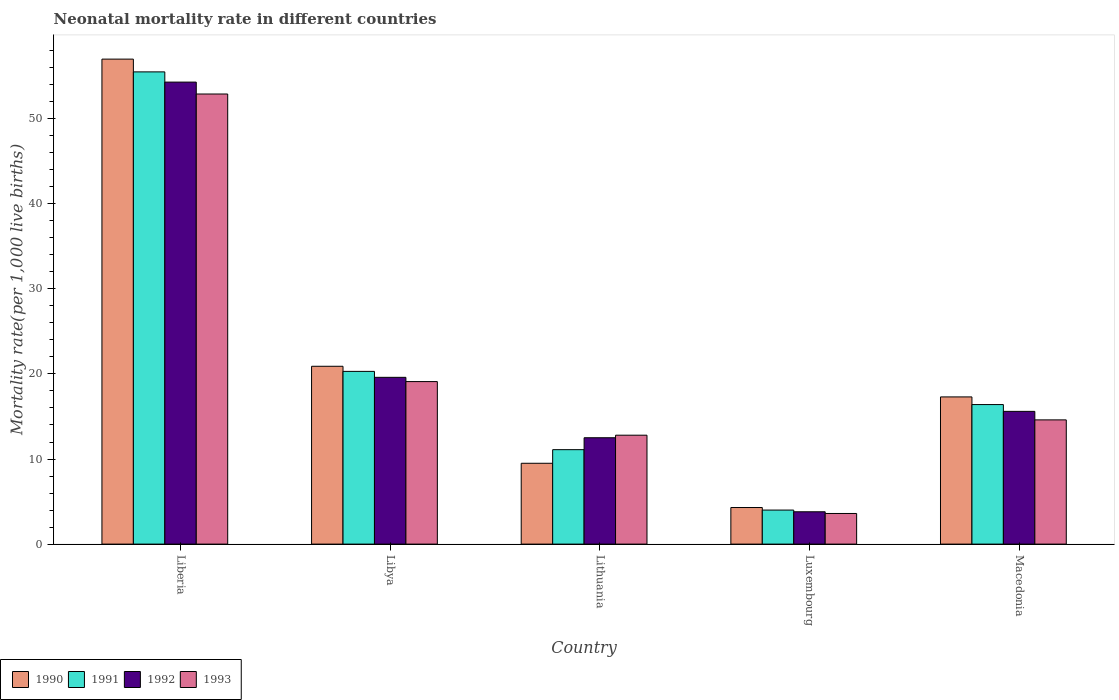How many different coloured bars are there?
Your answer should be very brief. 4. How many groups of bars are there?
Keep it short and to the point. 5. Are the number of bars on each tick of the X-axis equal?
Make the answer very short. Yes. How many bars are there on the 2nd tick from the left?
Make the answer very short. 4. How many bars are there on the 1st tick from the right?
Keep it short and to the point. 4. What is the label of the 1st group of bars from the left?
Your answer should be very brief. Liberia. In how many cases, is the number of bars for a given country not equal to the number of legend labels?
Your answer should be compact. 0. Across all countries, what is the maximum neonatal mortality rate in 1992?
Ensure brevity in your answer.  54.3. Across all countries, what is the minimum neonatal mortality rate in 1991?
Keep it short and to the point. 4. In which country was the neonatal mortality rate in 1991 maximum?
Provide a short and direct response. Liberia. In which country was the neonatal mortality rate in 1991 minimum?
Make the answer very short. Luxembourg. What is the total neonatal mortality rate in 1992 in the graph?
Give a very brief answer. 105.8. What is the difference between the neonatal mortality rate in 1991 in Liberia and that in Macedonia?
Provide a short and direct response. 39.1. What is the average neonatal mortality rate in 1992 per country?
Your answer should be compact. 21.16. What is the difference between the neonatal mortality rate of/in 1992 and neonatal mortality rate of/in 1993 in Luxembourg?
Ensure brevity in your answer.  0.2. In how many countries, is the neonatal mortality rate in 1991 greater than 14?
Provide a succinct answer. 3. What is the ratio of the neonatal mortality rate in 1992 in Liberia to that in Libya?
Provide a succinct answer. 2.77. Is the neonatal mortality rate in 1990 in Lithuania less than that in Macedonia?
Ensure brevity in your answer.  Yes. Is the difference between the neonatal mortality rate in 1992 in Libya and Macedonia greater than the difference between the neonatal mortality rate in 1993 in Libya and Macedonia?
Give a very brief answer. No. What is the difference between the highest and the second highest neonatal mortality rate in 1993?
Offer a terse response. -33.8. What is the difference between the highest and the lowest neonatal mortality rate in 1992?
Ensure brevity in your answer.  50.5. Is it the case that in every country, the sum of the neonatal mortality rate in 1992 and neonatal mortality rate in 1993 is greater than the sum of neonatal mortality rate in 1990 and neonatal mortality rate in 1991?
Provide a succinct answer. No. How many bars are there?
Make the answer very short. 20. Are all the bars in the graph horizontal?
Your answer should be compact. No. How many countries are there in the graph?
Make the answer very short. 5. Are the values on the major ticks of Y-axis written in scientific E-notation?
Make the answer very short. No. Does the graph contain any zero values?
Your response must be concise. No. Where does the legend appear in the graph?
Your answer should be very brief. Bottom left. How many legend labels are there?
Your answer should be very brief. 4. How are the legend labels stacked?
Offer a very short reply. Horizontal. What is the title of the graph?
Provide a succinct answer. Neonatal mortality rate in different countries. Does "2004" appear as one of the legend labels in the graph?
Your answer should be very brief. No. What is the label or title of the Y-axis?
Offer a very short reply. Mortality rate(per 1,0 live births). What is the Mortality rate(per 1,000 live births) of 1990 in Liberia?
Give a very brief answer. 57. What is the Mortality rate(per 1,000 live births) in 1991 in Liberia?
Offer a very short reply. 55.5. What is the Mortality rate(per 1,000 live births) in 1992 in Liberia?
Keep it short and to the point. 54.3. What is the Mortality rate(per 1,000 live births) in 1993 in Liberia?
Offer a very short reply. 52.9. What is the Mortality rate(per 1,000 live births) of 1990 in Libya?
Your answer should be very brief. 20.9. What is the Mortality rate(per 1,000 live births) in 1991 in Libya?
Your response must be concise. 20.3. What is the Mortality rate(per 1,000 live births) in 1992 in Libya?
Offer a terse response. 19.6. What is the Mortality rate(per 1,000 live births) in 1990 in Lithuania?
Ensure brevity in your answer.  9.5. What is the Mortality rate(per 1,000 live births) in 1991 in Lithuania?
Keep it short and to the point. 11.1. What is the Mortality rate(per 1,000 live births) in 1992 in Lithuania?
Provide a succinct answer. 12.5. What is the Mortality rate(per 1,000 live births) of 1993 in Lithuania?
Provide a succinct answer. 12.8. What is the Mortality rate(per 1,000 live births) of 1991 in Luxembourg?
Your answer should be very brief. 4. What is the Mortality rate(per 1,000 live births) of 1992 in Luxembourg?
Provide a short and direct response. 3.8. What is the Mortality rate(per 1,000 live births) in 1990 in Macedonia?
Make the answer very short. 17.3. What is the Mortality rate(per 1,000 live births) of 1993 in Macedonia?
Make the answer very short. 14.6. Across all countries, what is the maximum Mortality rate(per 1,000 live births) in 1991?
Provide a short and direct response. 55.5. Across all countries, what is the maximum Mortality rate(per 1,000 live births) in 1992?
Give a very brief answer. 54.3. Across all countries, what is the maximum Mortality rate(per 1,000 live births) of 1993?
Provide a short and direct response. 52.9. Across all countries, what is the minimum Mortality rate(per 1,000 live births) of 1990?
Keep it short and to the point. 4.3. Across all countries, what is the minimum Mortality rate(per 1,000 live births) of 1991?
Provide a short and direct response. 4. Across all countries, what is the minimum Mortality rate(per 1,000 live births) of 1992?
Give a very brief answer. 3.8. Across all countries, what is the minimum Mortality rate(per 1,000 live births) of 1993?
Provide a short and direct response. 3.6. What is the total Mortality rate(per 1,000 live births) in 1990 in the graph?
Your answer should be very brief. 109. What is the total Mortality rate(per 1,000 live births) in 1991 in the graph?
Give a very brief answer. 107.3. What is the total Mortality rate(per 1,000 live births) of 1992 in the graph?
Your response must be concise. 105.8. What is the total Mortality rate(per 1,000 live births) in 1993 in the graph?
Your response must be concise. 103. What is the difference between the Mortality rate(per 1,000 live births) in 1990 in Liberia and that in Libya?
Make the answer very short. 36.1. What is the difference between the Mortality rate(per 1,000 live births) in 1991 in Liberia and that in Libya?
Ensure brevity in your answer.  35.2. What is the difference between the Mortality rate(per 1,000 live births) of 1992 in Liberia and that in Libya?
Provide a succinct answer. 34.7. What is the difference between the Mortality rate(per 1,000 live births) of 1993 in Liberia and that in Libya?
Your answer should be compact. 33.8. What is the difference between the Mortality rate(per 1,000 live births) of 1990 in Liberia and that in Lithuania?
Keep it short and to the point. 47.5. What is the difference between the Mortality rate(per 1,000 live births) of 1991 in Liberia and that in Lithuania?
Your answer should be compact. 44.4. What is the difference between the Mortality rate(per 1,000 live births) of 1992 in Liberia and that in Lithuania?
Keep it short and to the point. 41.8. What is the difference between the Mortality rate(per 1,000 live births) in 1993 in Liberia and that in Lithuania?
Your answer should be very brief. 40.1. What is the difference between the Mortality rate(per 1,000 live births) of 1990 in Liberia and that in Luxembourg?
Provide a short and direct response. 52.7. What is the difference between the Mortality rate(per 1,000 live births) in 1991 in Liberia and that in Luxembourg?
Provide a succinct answer. 51.5. What is the difference between the Mortality rate(per 1,000 live births) in 1992 in Liberia and that in Luxembourg?
Give a very brief answer. 50.5. What is the difference between the Mortality rate(per 1,000 live births) in 1993 in Liberia and that in Luxembourg?
Ensure brevity in your answer.  49.3. What is the difference between the Mortality rate(per 1,000 live births) of 1990 in Liberia and that in Macedonia?
Ensure brevity in your answer.  39.7. What is the difference between the Mortality rate(per 1,000 live births) of 1991 in Liberia and that in Macedonia?
Your response must be concise. 39.1. What is the difference between the Mortality rate(per 1,000 live births) of 1992 in Liberia and that in Macedonia?
Offer a very short reply. 38.7. What is the difference between the Mortality rate(per 1,000 live births) of 1993 in Liberia and that in Macedonia?
Provide a short and direct response. 38.3. What is the difference between the Mortality rate(per 1,000 live births) in 1990 in Libya and that in Lithuania?
Keep it short and to the point. 11.4. What is the difference between the Mortality rate(per 1,000 live births) in 1992 in Libya and that in Lithuania?
Keep it short and to the point. 7.1. What is the difference between the Mortality rate(per 1,000 live births) of 1993 in Libya and that in Lithuania?
Keep it short and to the point. 6.3. What is the difference between the Mortality rate(per 1,000 live births) of 1990 in Libya and that in Luxembourg?
Your answer should be compact. 16.6. What is the difference between the Mortality rate(per 1,000 live births) in 1993 in Libya and that in Luxembourg?
Your response must be concise. 15.5. What is the difference between the Mortality rate(per 1,000 live births) of 1990 in Libya and that in Macedonia?
Give a very brief answer. 3.6. What is the difference between the Mortality rate(per 1,000 live births) in 1991 in Libya and that in Macedonia?
Keep it short and to the point. 3.9. What is the difference between the Mortality rate(per 1,000 live births) of 1992 in Libya and that in Macedonia?
Provide a succinct answer. 4. What is the difference between the Mortality rate(per 1,000 live births) of 1993 in Libya and that in Macedonia?
Give a very brief answer. 4.5. What is the difference between the Mortality rate(per 1,000 live births) in 1990 in Lithuania and that in Luxembourg?
Keep it short and to the point. 5.2. What is the difference between the Mortality rate(per 1,000 live births) of 1991 in Lithuania and that in Luxembourg?
Offer a terse response. 7.1. What is the difference between the Mortality rate(per 1,000 live births) of 1993 in Lithuania and that in Luxembourg?
Your answer should be very brief. 9.2. What is the difference between the Mortality rate(per 1,000 live births) in 1990 in Lithuania and that in Macedonia?
Offer a terse response. -7.8. What is the difference between the Mortality rate(per 1,000 live births) in 1992 in Lithuania and that in Macedonia?
Your response must be concise. -3.1. What is the difference between the Mortality rate(per 1,000 live births) in 1992 in Luxembourg and that in Macedonia?
Give a very brief answer. -11.8. What is the difference between the Mortality rate(per 1,000 live births) in 1993 in Luxembourg and that in Macedonia?
Your response must be concise. -11. What is the difference between the Mortality rate(per 1,000 live births) in 1990 in Liberia and the Mortality rate(per 1,000 live births) in 1991 in Libya?
Ensure brevity in your answer.  36.7. What is the difference between the Mortality rate(per 1,000 live births) in 1990 in Liberia and the Mortality rate(per 1,000 live births) in 1992 in Libya?
Your answer should be compact. 37.4. What is the difference between the Mortality rate(per 1,000 live births) in 1990 in Liberia and the Mortality rate(per 1,000 live births) in 1993 in Libya?
Make the answer very short. 37.9. What is the difference between the Mortality rate(per 1,000 live births) in 1991 in Liberia and the Mortality rate(per 1,000 live births) in 1992 in Libya?
Your answer should be compact. 35.9. What is the difference between the Mortality rate(per 1,000 live births) in 1991 in Liberia and the Mortality rate(per 1,000 live births) in 1993 in Libya?
Provide a succinct answer. 36.4. What is the difference between the Mortality rate(per 1,000 live births) of 1992 in Liberia and the Mortality rate(per 1,000 live births) of 1993 in Libya?
Provide a succinct answer. 35.2. What is the difference between the Mortality rate(per 1,000 live births) of 1990 in Liberia and the Mortality rate(per 1,000 live births) of 1991 in Lithuania?
Your answer should be very brief. 45.9. What is the difference between the Mortality rate(per 1,000 live births) in 1990 in Liberia and the Mortality rate(per 1,000 live births) in 1992 in Lithuania?
Your answer should be very brief. 44.5. What is the difference between the Mortality rate(per 1,000 live births) of 1990 in Liberia and the Mortality rate(per 1,000 live births) of 1993 in Lithuania?
Ensure brevity in your answer.  44.2. What is the difference between the Mortality rate(per 1,000 live births) in 1991 in Liberia and the Mortality rate(per 1,000 live births) in 1992 in Lithuania?
Offer a terse response. 43. What is the difference between the Mortality rate(per 1,000 live births) in 1991 in Liberia and the Mortality rate(per 1,000 live births) in 1993 in Lithuania?
Your answer should be compact. 42.7. What is the difference between the Mortality rate(per 1,000 live births) of 1992 in Liberia and the Mortality rate(per 1,000 live births) of 1993 in Lithuania?
Your answer should be very brief. 41.5. What is the difference between the Mortality rate(per 1,000 live births) of 1990 in Liberia and the Mortality rate(per 1,000 live births) of 1992 in Luxembourg?
Your answer should be very brief. 53.2. What is the difference between the Mortality rate(per 1,000 live births) of 1990 in Liberia and the Mortality rate(per 1,000 live births) of 1993 in Luxembourg?
Offer a terse response. 53.4. What is the difference between the Mortality rate(per 1,000 live births) of 1991 in Liberia and the Mortality rate(per 1,000 live births) of 1992 in Luxembourg?
Offer a very short reply. 51.7. What is the difference between the Mortality rate(per 1,000 live births) in 1991 in Liberia and the Mortality rate(per 1,000 live births) in 1993 in Luxembourg?
Give a very brief answer. 51.9. What is the difference between the Mortality rate(per 1,000 live births) of 1992 in Liberia and the Mortality rate(per 1,000 live births) of 1993 in Luxembourg?
Your answer should be very brief. 50.7. What is the difference between the Mortality rate(per 1,000 live births) of 1990 in Liberia and the Mortality rate(per 1,000 live births) of 1991 in Macedonia?
Keep it short and to the point. 40.6. What is the difference between the Mortality rate(per 1,000 live births) of 1990 in Liberia and the Mortality rate(per 1,000 live births) of 1992 in Macedonia?
Ensure brevity in your answer.  41.4. What is the difference between the Mortality rate(per 1,000 live births) in 1990 in Liberia and the Mortality rate(per 1,000 live births) in 1993 in Macedonia?
Provide a succinct answer. 42.4. What is the difference between the Mortality rate(per 1,000 live births) of 1991 in Liberia and the Mortality rate(per 1,000 live births) of 1992 in Macedonia?
Ensure brevity in your answer.  39.9. What is the difference between the Mortality rate(per 1,000 live births) in 1991 in Liberia and the Mortality rate(per 1,000 live births) in 1993 in Macedonia?
Provide a succinct answer. 40.9. What is the difference between the Mortality rate(per 1,000 live births) of 1992 in Liberia and the Mortality rate(per 1,000 live births) of 1993 in Macedonia?
Keep it short and to the point. 39.7. What is the difference between the Mortality rate(per 1,000 live births) of 1991 in Libya and the Mortality rate(per 1,000 live births) of 1993 in Lithuania?
Offer a terse response. 7.5. What is the difference between the Mortality rate(per 1,000 live births) of 1992 in Libya and the Mortality rate(per 1,000 live births) of 1993 in Lithuania?
Provide a short and direct response. 6.8. What is the difference between the Mortality rate(per 1,000 live births) of 1990 in Libya and the Mortality rate(per 1,000 live births) of 1993 in Luxembourg?
Your answer should be very brief. 17.3. What is the difference between the Mortality rate(per 1,000 live births) of 1991 in Libya and the Mortality rate(per 1,000 live births) of 1992 in Luxembourg?
Your answer should be compact. 16.5. What is the difference between the Mortality rate(per 1,000 live births) of 1992 in Libya and the Mortality rate(per 1,000 live births) of 1993 in Luxembourg?
Your answer should be very brief. 16. What is the difference between the Mortality rate(per 1,000 live births) of 1990 in Libya and the Mortality rate(per 1,000 live births) of 1991 in Macedonia?
Your answer should be very brief. 4.5. What is the difference between the Mortality rate(per 1,000 live births) of 1990 in Libya and the Mortality rate(per 1,000 live births) of 1992 in Macedonia?
Your answer should be compact. 5.3. What is the difference between the Mortality rate(per 1,000 live births) in 1990 in Lithuania and the Mortality rate(per 1,000 live births) in 1991 in Luxembourg?
Make the answer very short. 5.5. What is the difference between the Mortality rate(per 1,000 live births) of 1990 in Lithuania and the Mortality rate(per 1,000 live births) of 1992 in Luxembourg?
Offer a very short reply. 5.7. What is the difference between the Mortality rate(per 1,000 live births) of 1990 in Lithuania and the Mortality rate(per 1,000 live births) of 1992 in Macedonia?
Your answer should be very brief. -6.1. What is the difference between the Mortality rate(per 1,000 live births) of 1990 in Lithuania and the Mortality rate(per 1,000 live births) of 1993 in Macedonia?
Offer a very short reply. -5.1. What is the difference between the Mortality rate(per 1,000 live births) in 1991 in Lithuania and the Mortality rate(per 1,000 live births) in 1992 in Macedonia?
Offer a terse response. -4.5. What is the difference between the Mortality rate(per 1,000 live births) in 1991 in Lithuania and the Mortality rate(per 1,000 live births) in 1993 in Macedonia?
Keep it short and to the point. -3.5. What is the difference between the Mortality rate(per 1,000 live births) in 1990 in Luxembourg and the Mortality rate(per 1,000 live births) in 1993 in Macedonia?
Provide a short and direct response. -10.3. What is the average Mortality rate(per 1,000 live births) in 1990 per country?
Provide a short and direct response. 21.8. What is the average Mortality rate(per 1,000 live births) of 1991 per country?
Provide a short and direct response. 21.46. What is the average Mortality rate(per 1,000 live births) in 1992 per country?
Keep it short and to the point. 21.16. What is the average Mortality rate(per 1,000 live births) of 1993 per country?
Your answer should be compact. 20.6. What is the difference between the Mortality rate(per 1,000 live births) of 1990 and Mortality rate(per 1,000 live births) of 1993 in Liberia?
Provide a succinct answer. 4.1. What is the difference between the Mortality rate(per 1,000 live births) of 1992 and Mortality rate(per 1,000 live births) of 1993 in Liberia?
Make the answer very short. 1.4. What is the difference between the Mortality rate(per 1,000 live births) of 1990 and Mortality rate(per 1,000 live births) of 1993 in Libya?
Keep it short and to the point. 1.8. What is the difference between the Mortality rate(per 1,000 live births) in 1990 and Mortality rate(per 1,000 live births) in 1991 in Lithuania?
Offer a terse response. -1.6. What is the difference between the Mortality rate(per 1,000 live births) in 1990 and Mortality rate(per 1,000 live births) in 1992 in Lithuania?
Give a very brief answer. -3. What is the difference between the Mortality rate(per 1,000 live births) in 1990 and Mortality rate(per 1,000 live births) in 1991 in Luxembourg?
Offer a terse response. 0.3. What is the difference between the Mortality rate(per 1,000 live births) of 1990 and Mortality rate(per 1,000 live births) of 1992 in Luxembourg?
Keep it short and to the point. 0.5. What is the difference between the Mortality rate(per 1,000 live births) of 1991 and Mortality rate(per 1,000 live births) of 1992 in Luxembourg?
Offer a very short reply. 0.2. What is the difference between the Mortality rate(per 1,000 live births) in 1991 and Mortality rate(per 1,000 live births) in 1993 in Luxembourg?
Your answer should be very brief. 0.4. What is the difference between the Mortality rate(per 1,000 live births) in 1991 and Mortality rate(per 1,000 live births) in 1992 in Macedonia?
Provide a short and direct response. 0.8. What is the difference between the Mortality rate(per 1,000 live births) in 1991 and Mortality rate(per 1,000 live births) in 1993 in Macedonia?
Make the answer very short. 1.8. What is the ratio of the Mortality rate(per 1,000 live births) in 1990 in Liberia to that in Libya?
Your answer should be very brief. 2.73. What is the ratio of the Mortality rate(per 1,000 live births) in 1991 in Liberia to that in Libya?
Ensure brevity in your answer.  2.73. What is the ratio of the Mortality rate(per 1,000 live births) in 1992 in Liberia to that in Libya?
Your answer should be compact. 2.77. What is the ratio of the Mortality rate(per 1,000 live births) of 1993 in Liberia to that in Libya?
Make the answer very short. 2.77. What is the ratio of the Mortality rate(per 1,000 live births) of 1992 in Liberia to that in Lithuania?
Your answer should be compact. 4.34. What is the ratio of the Mortality rate(per 1,000 live births) in 1993 in Liberia to that in Lithuania?
Offer a terse response. 4.13. What is the ratio of the Mortality rate(per 1,000 live births) of 1990 in Liberia to that in Luxembourg?
Make the answer very short. 13.26. What is the ratio of the Mortality rate(per 1,000 live births) of 1991 in Liberia to that in Luxembourg?
Give a very brief answer. 13.88. What is the ratio of the Mortality rate(per 1,000 live births) of 1992 in Liberia to that in Luxembourg?
Make the answer very short. 14.29. What is the ratio of the Mortality rate(per 1,000 live births) in 1993 in Liberia to that in Luxembourg?
Offer a very short reply. 14.69. What is the ratio of the Mortality rate(per 1,000 live births) in 1990 in Liberia to that in Macedonia?
Offer a terse response. 3.29. What is the ratio of the Mortality rate(per 1,000 live births) in 1991 in Liberia to that in Macedonia?
Ensure brevity in your answer.  3.38. What is the ratio of the Mortality rate(per 1,000 live births) in 1992 in Liberia to that in Macedonia?
Offer a very short reply. 3.48. What is the ratio of the Mortality rate(per 1,000 live births) of 1993 in Liberia to that in Macedonia?
Offer a terse response. 3.62. What is the ratio of the Mortality rate(per 1,000 live births) in 1990 in Libya to that in Lithuania?
Offer a terse response. 2.2. What is the ratio of the Mortality rate(per 1,000 live births) of 1991 in Libya to that in Lithuania?
Keep it short and to the point. 1.83. What is the ratio of the Mortality rate(per 1,000 live births) of 1992 in Libya to that in Lithuania?
Make the answer very short. 1.57. What is the ratio of the Mortality rate(per 1,000 live births) of 1993 in Libya to that in Lithuania?
Give a very brief answer. 1.49. What is the ratio of the Mortality rate(per 1,000 live births) of 1990 in Libya to that in Luxembourg?
Keep it short and to the point. 4.86. What is the ratio of the Mortality rate(per 1,000 live births) of 1991 in Libya to that in Luxembourg?
Make the answer very short. 5.08. What is the ratio of the Mortality rate(per 1,000 live births) of 1992 in Libya to that in Luxembourg?
Your answer should be very brief. 5.16. What is the ratio of the Mortality rate(per 1,000 live births) of 1993 in Libya to that in Luxembourg?
Give a very brief answer. 5.31. What is the ratio of the Mortality rate(per 1,000 live births) in 1990 in Libya to that in Macedonia?
Your response must be concise. 1.21. What is the ratio of the Mortality rate(per 1,000 live births) of 1991 in Libya to that in Macedonia?
Offer a very short reply. 1.24. What is the ratio of the Mortality rate(per 1,000 live births) of 1992 in Libya to that in Macedonia?
Keep it short and to the point. 1.26. What is the ratio of the Mortality rate(per 1,000 live births) in 1993 in Libya to that in Macedonia?
Your answer should be very brief. 1.31. What is the ratio of the Mortality rate(per 1,000 live births) of 1990 in Lithuania to that in Luxembourg?
Offer a very short reply. 2.21. What is the ratio of the Mortality rate(per 1,000 live births) of 1991 in Lithuania to that in Luxembourg?
Make the answer very short. 2.77. What is the ratio of the Mortality rate(per 1,000 live births) of 1992 in Lithuania to that in Luxembourg?
Your answer should be very brief. 3.29. What is the ratio of the Mortality rate(per 1,000 live births) in 1993 in Lithuania to that in Luxembourg?
Offer a terse response. 3.56. What is the ratio of the Mortality rate(per 1,000 live births) in 1990 in Lithuania to that in Macedonia?
Ensure brevity in your answer.  0.55. What is the ratio of the Mortality rate(per 1,000 live births) of 1991 in Lithuania to that in Macedonia?
Your answer should be compact. 0.68. What is the ratio of the Mortality rate(per 1,000 live births) in 1992 in Lithuania to that in Macedonia?
Offer a terse response. 0.8. What is the ratio of the Mortality rate(per 1,000 live births) of 1993 in Lithuania to that in Macedonia?
Make the answer very short. 0.88. What is the ratio of the Mortality rate(per 1,000 live births) in 1990 in Luxembourg to that in Macedonia?
Provide a short and direct response. 0.25. What is the ratio of the Mortality rate(per 1,000 live births) of 1991 in Luxembourg to that in Macedonia?
Your answer should be very brief. 0.24. What is the ratio of the Mortality rate(per 1,000 live births) in 1992 in Luxembourg to that in Macedonia?
Make the answer very short. 0.24. What is the ratio of the Mortality rate(per 1,000 live births) of 1993 in Luxembourg to that in Macedonia?
Ensure brevity in your answer.  0.25. What is the difference between the highest and the second highest Mortality rate(per 1,000 live births) in 1990?
Ensure brevity in your answer.  36.1. What is the difference between the highest and the second highest Mortality rate(per 1,000 live births) of 1991?
Give a very brief answer. 35.2. What is the difference between the highest and the second highest Mortality rate(per 1,000 live births) in 1992?
Your answer should be very brief. 34.7. What is the difference between the highest and the second highest Mortality rate(per 1,000 live births) of 1993?
Give a very brief answer. 33.8. What is the difference between the highest and the lowest Mortality rate(per 1,000 live births) in 1990?
Give a very brief answer. 52.7. What is the difference between the highest and the lowest Mortality rate(per 1,000 live births) of 1991?
Your response must be concise. 51.5. What is the difference between the highest and the lowest Mortality rate(per 1,000 live births) of 1992?
Ensure brevity in your answer.  50.5. What is the difference between the highest and the lowest Mortality rate(per 1,000 live births) of 1993?
Your answer should be very brief. 49.3. 